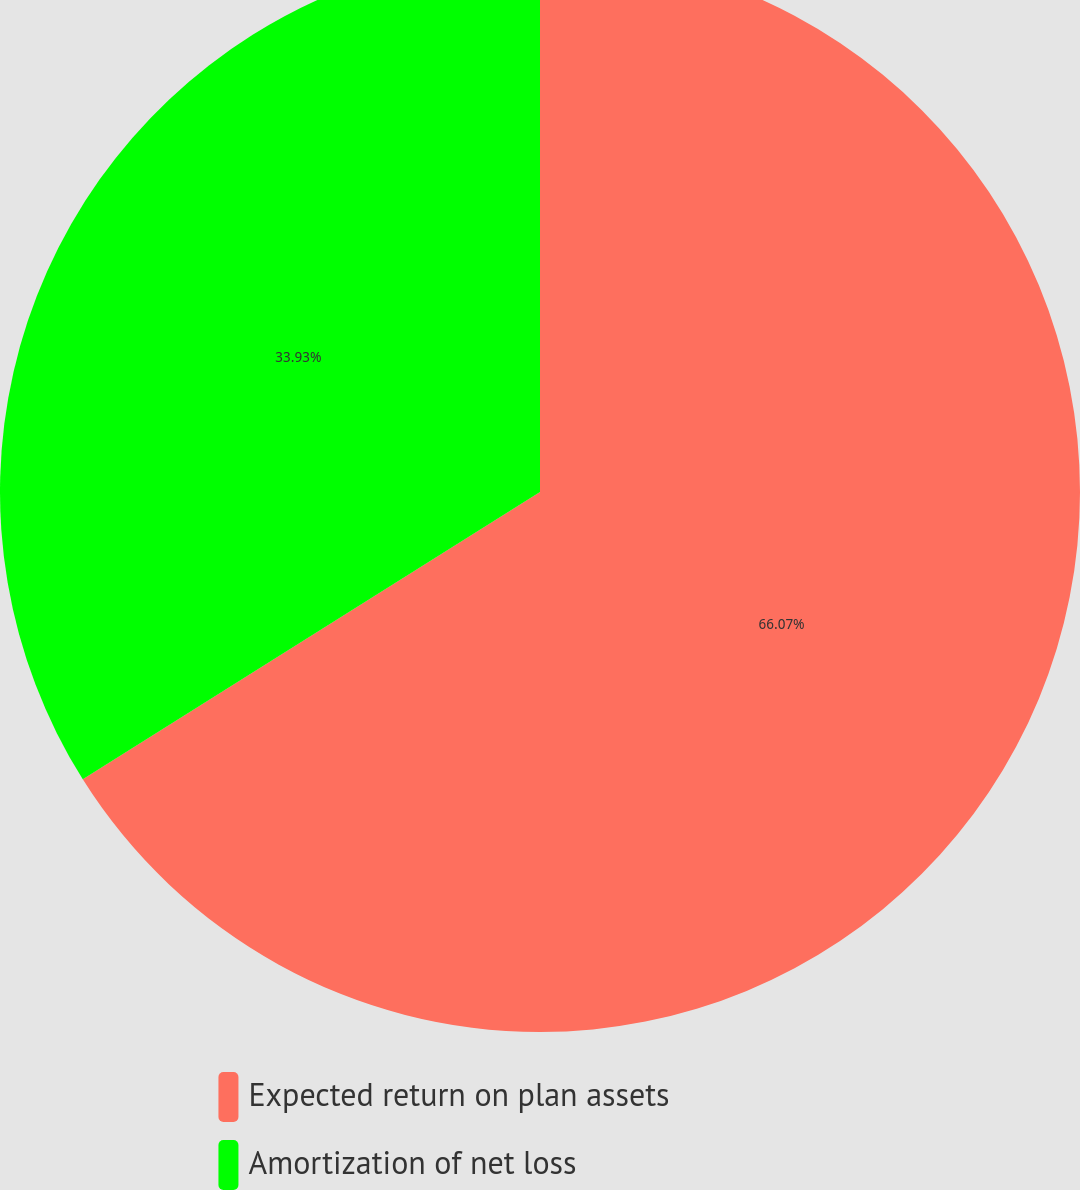Convert chart. <chart><loc_0><loc_0><loc_500><loc_500><pie_chart><fcel>Expected return on plan assets<fcel>Amortization of net loss<nl><fcel>66.07%<fcel>33.93%<nl></chart> 